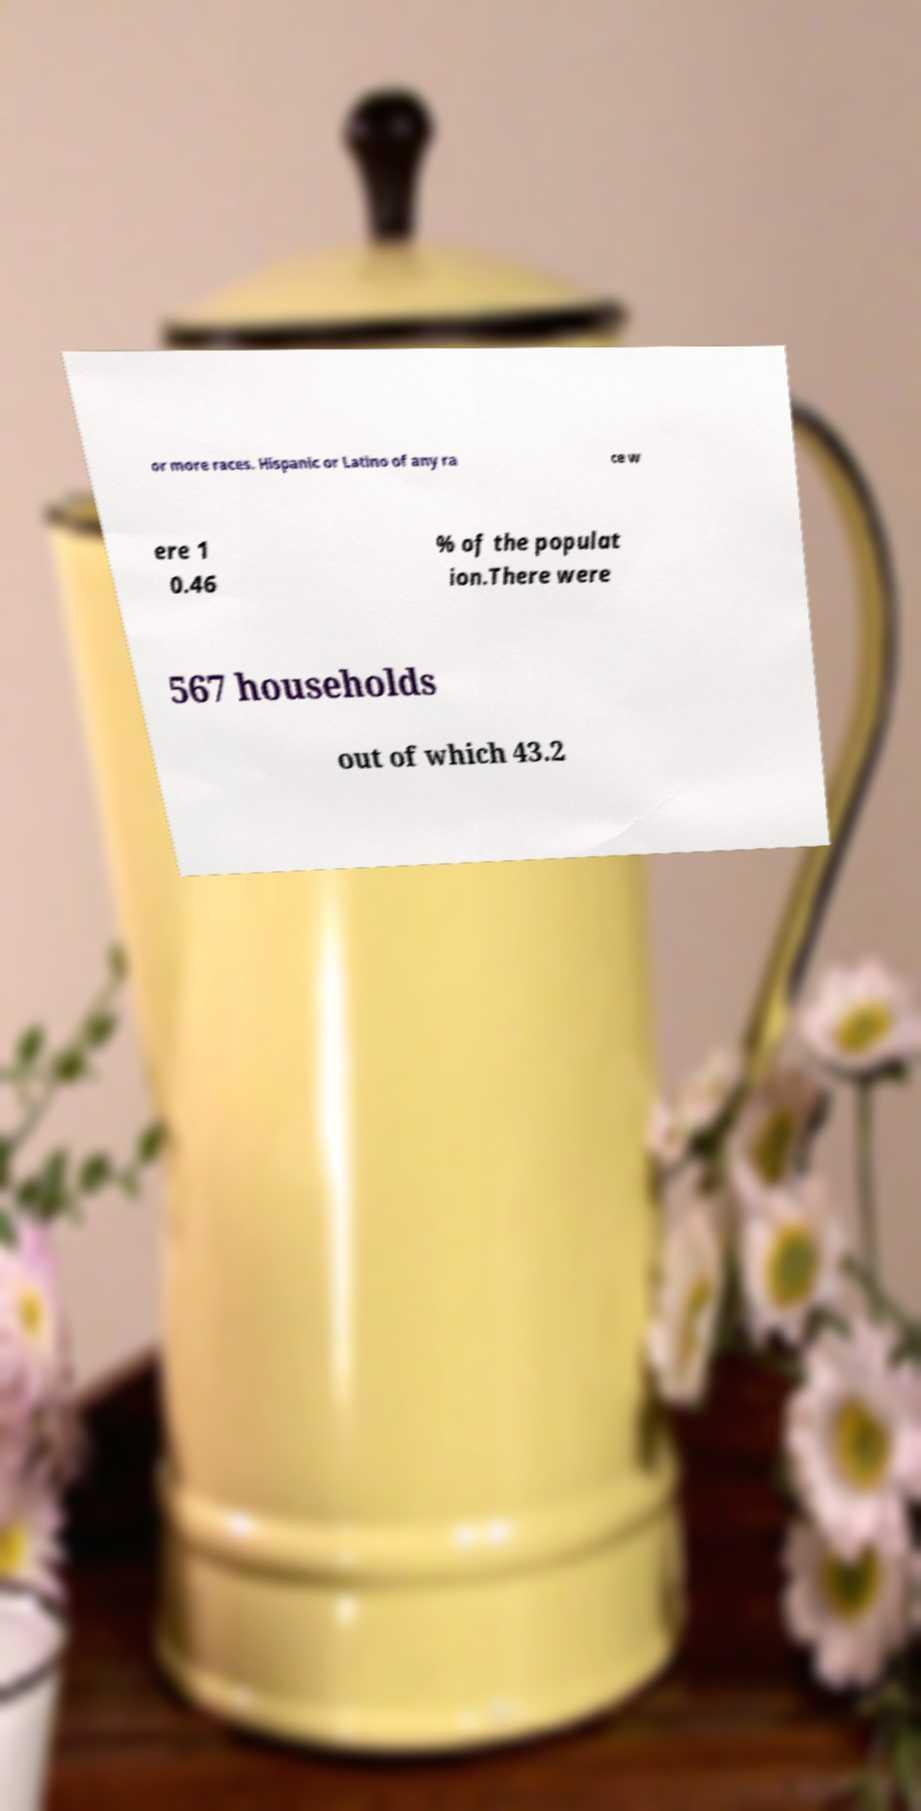What messages or text are displayed in this image? I need them in a readable, typed format. or more races. Hispanic or Latino of any ra ce w ere 1 0.46 % of the populat ion.There were 567 households out of which 43.2 